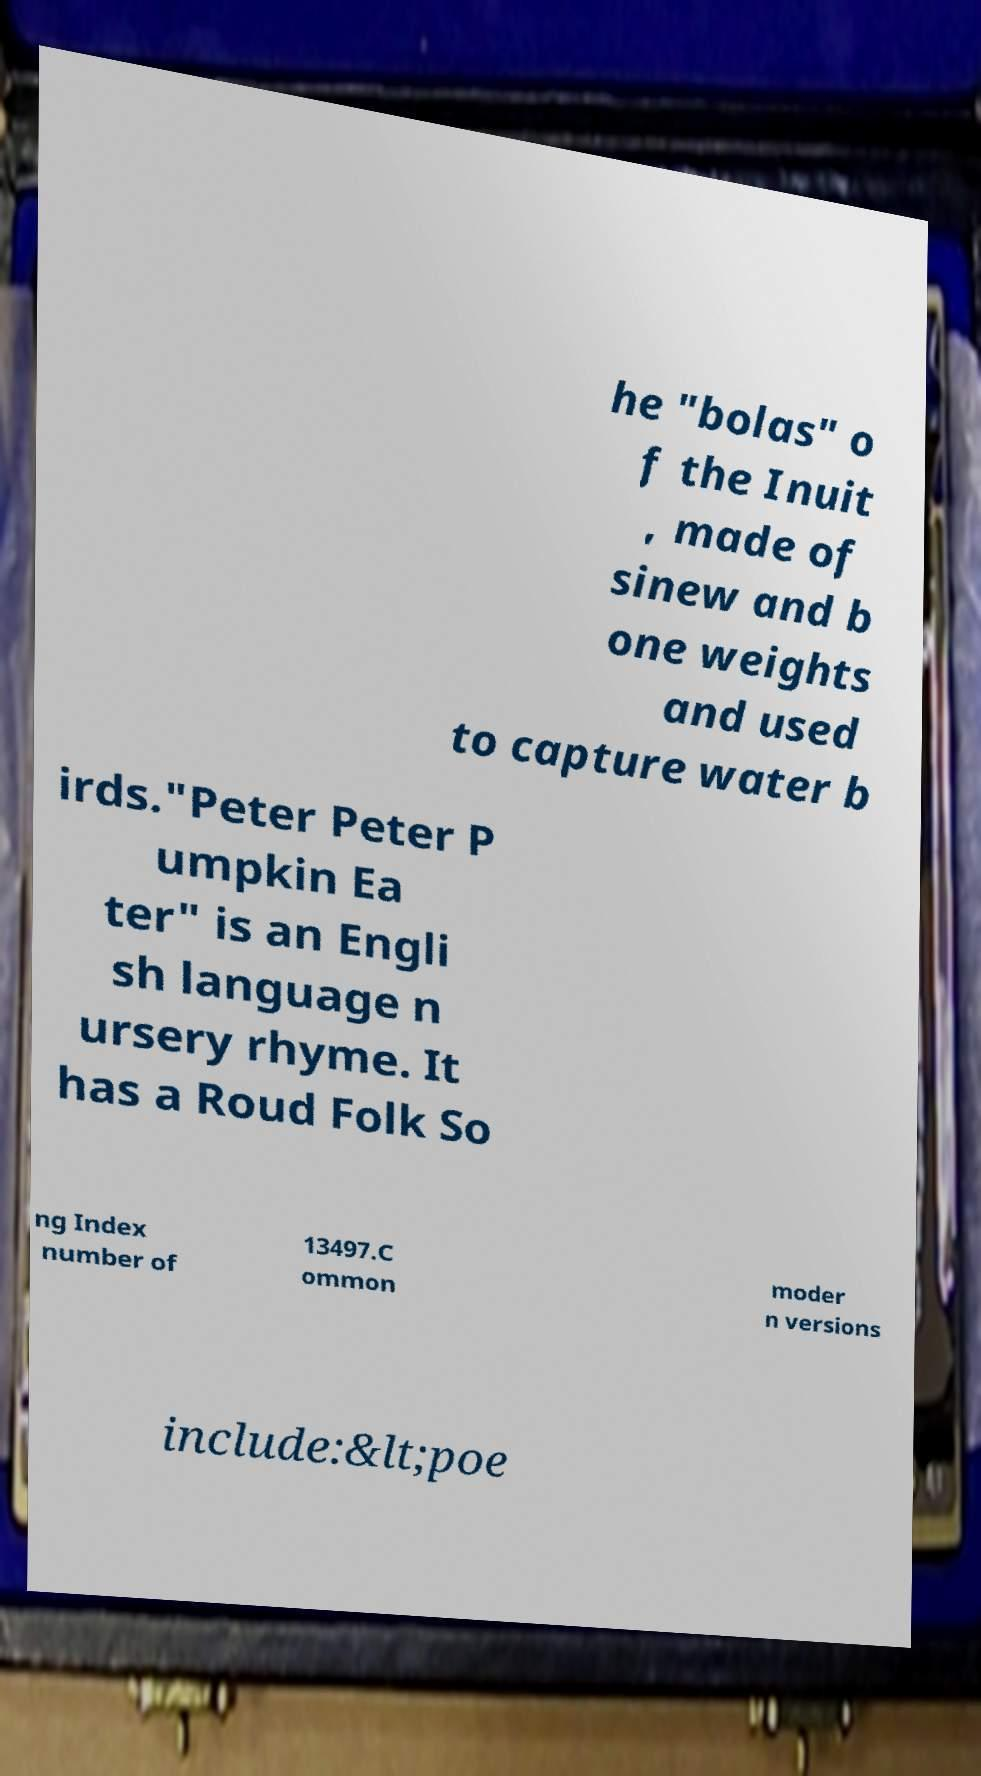I need the written content from this picture converted into text. Can you do that? he "bolas" o f the Inuit , made of sinew and b one weights and used to capture water b irds."Peter Peter P umpkin Ea ter" is an Engli sh language n ursery rhyme. It has a Roud Folk So ng Index number of 13497.C ommon moder n versions include:&lt;poe 